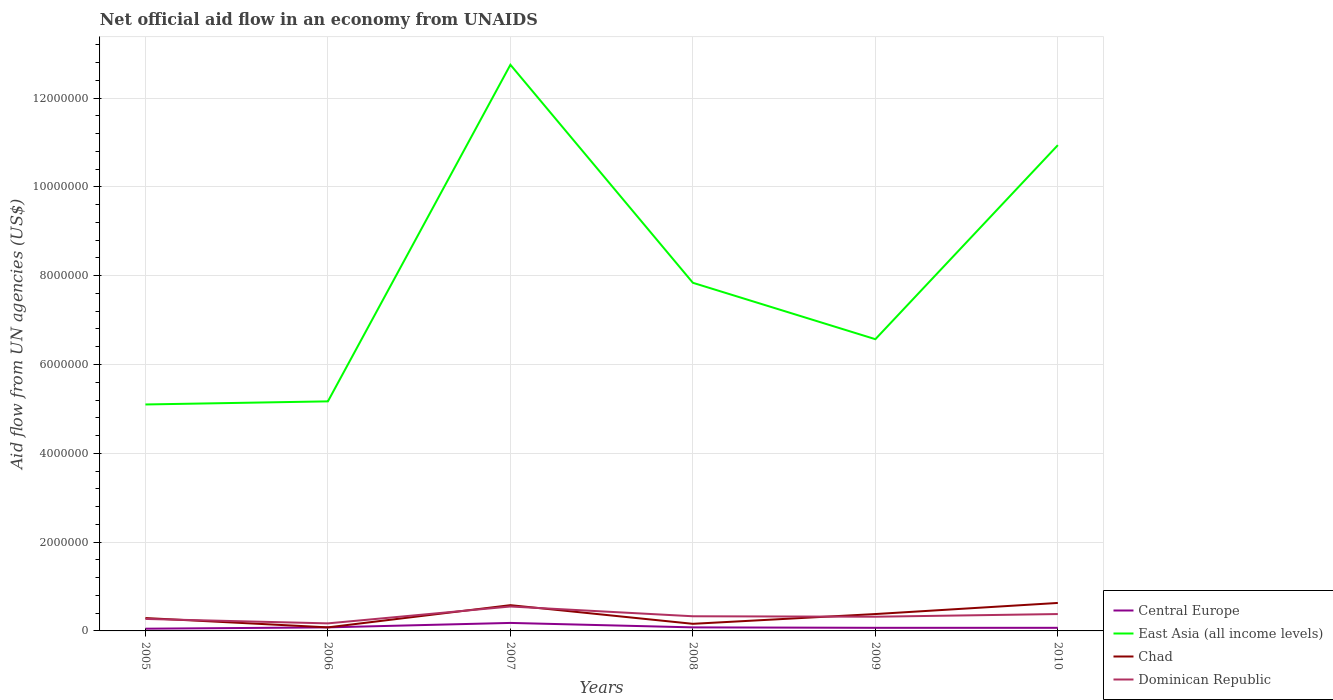How many different coloured lines are there?
Offer a very short reply. 4. Across all years, what is the maximum net official aid flow in Chad?
Your response must be concise. 8.00e+04. What is the total net official aid flow in Central Europe in the graph?
Make the answer very short. 0. What is the difference between the highest and the second highest net official aid flow in Chad?
Ensure brevity in your answer.  5.50e+05. What is the difference between the highest and the lowest net official aid flow in East Asia (all income levels)?
Offer a terse response. 2. How many years are there in the graph?
Keep it short and to the point. 6. What is the difference between two consecutive major ticks on the Y-axis?
Provide a succinct answer. 2.00e+06. How many legend labels are there?
Your answer should be very brief. 4. What is the title of the graph?
Offer a very short reply. Net official aid flow in an economy from UNAIDS. Does "France" appear as one of the legend labels in the graph?
Your response must be concise. No. What is the label or title of the X-axis?
Keep it short and to the point. Years. What is the label or title of the Y-axis?
Keep it short and to the point. Aid flow from UN agencies (US$). What is the Aid flow from UN agencies (US$) of Central Europe in 2005?
Ensure brevity in your answer.  5.00e+04. What is the Aid flow from UN agencies (US$) of East Asia (all income levels) in 2005?
Your answer should be compact. 5.10e+06. What is the Aid flow from UN agencies (US$) in Dominican Republic in 2005?
Your answer should be very brief. 2.70e+05. What is the Aid flow from UN agencies (US$) of East Asia (all income levels) in 2006?
Give a very brief answer. 5.17e+06. What is the Aid flow from UN agencies (US$) of Dominican Republic in 2006?
Provide a succinct answer. 1.70e+05. What is the Aid flow from UN agencies (US$) of Central Europe in 2007?
Your response must be concise. 1.80e+05. What is the Aid flow from UN agencies (US$) in East Asia (all income levels) in 2007?
Keep it short and to the point. 1.28e+07. What is the Aid flow from UN agencies (US$) of Chad in 2007?
Provide a short and direct response. 5.80e+05. What is the Aid flow from UN agencies (US$) of Dominican Republic in 2007?
Keep it short and to the point. 5.50e+05. What is the Aid flow from UN agencies (US$) in East Asia (all income levels) in 2008?
Your response must be concise. 7.84e+06. What is the Aid flow from UN agencies (US$) in Chad in 2008?
Offer a very short reply. 1.60e+05. What is the Aid flow from UN agencies (US$) of Dominican Republic in 2008?
Keep it short and to the point. 3.30e+05. What is the Aid flow from UN agencies (US$) of East Asia (all income levels) in 2009?
Ensure brevity in your answer.  6.57e+06. What is the Aid flow from UN agencies (US$) of Chad in 2009?
Your response must be concise. 3.80e+05. What is the Aid flow from UN agencies (US$) in East Asia (all income levels) in 2010?
Give a very brief answer. 1.09e+07. What is the Aid flow from UN agencies (US$) in Chad in 2010?
Make the answer very short. 6.30e+05. What is the Aid flow from UN agencies (US$) in Dominican Republic in 2010?
Your answer should be very brief. 3.80e+05. Across all years, what is the maximum Aid flow from UN agencies (US$) in East Asia (all income levels)?
Make the answer very short. 1.28e+07. Across all years, what is the maximum Aid flow from UN agencies (US$) in Chad?
Provide a short and direct response. 6.30e+05. Across all years, what is the maximum Aid flow from UN agencies (US$) in Dominican Republic?
Your answer should be very brief. 5.50e+05. Across all years, what is the minimum Aid flow from UN agencies (US$) in Central Europe?
Provide a short and direct response. 5.00e+04. Across all years, what is the minimum Aid flow from UN agencies (US$) in East Asia (all income levels)?
Provide a succinct answer. 5.10e+06. Across all years, what is the minimum Aid flow from UN agencies (US$) in Dominican Republic?
Keep it short and to the point. 1.70e+05. What is the total Aid flow from UN agencies (US$) of Central Europe in the graph?
Offer a very short reply. 5.30e+05. What is the total Aid flow from UN agencies (US$) in East Asia (all income levels) in the graph?
Keep it short and to the point. 4.84e+07. What is the total Aid flow from UN agencies (US$) of Chad in the graph?
Keep it short and to the point. 2.12e+06. What is the total Aid flow from UN agencies (US$) in Dominican Republic in the graph?
Make the answer very short. 2.02e+06. What is the difference between the Aid flow from UN agencies (US$) of Dominican Republic in 2005 and that in 2006?
Your answer should be compact. 1.00e+05. What is the difference between the Aid flow from UN agencies (US$) in East Asia (all income levels) in 2005 and that in 2007?
Give a very brief answer. -7.65e+06. What is the difference between the Aid flow from UN agencies (US$) of Chad in 2005 and that in 2007?
Ensure brevity in your answer.  -2.90e+05. What is the difference between the Aid flow from UN agencies (US$) of Dominican Republic in 2005 and that in 2007?
Offer a terse response. -2.80e+05. What is the difference between the Aid flow from UN agencies (US$) in Central Europe in 2005 and that in 2008?
Offer a terse response. -3.00e+04. What is the difference between the Aid flow from UN agencies (US$) of East Asia (all income levels) in 2005 and that in 2008?
Provide a short and direct response. -2.74e+06. What is the difference between the Aid flow from UN agencies (US$) of Chad in 2005 and that in 2008?
Make the answer very short. 1.30e+05. What is the difference between the Aid flow from UN agencies (US$) in Central Europe in 2005 and that in 2009?
Give a very brief answer. -2.00e+04. What is the difference between the Aid flow from UN agencies (US$) in East Asia (all income levels) in 2005 and that in 2009?
Offer a terse response. -1.47e+06. What is the difference between the Aid flow from UN agencies (US$) of Chad in 2005 and that in 2009?
Offer a very short reply. -9.00e+04. What is the difference between the Aid flow from UN agencies (US$) of Dominican Republic in 2005 and that in 2009?
Offer a very short reply. -5.00e+04. What is the difference between the Aid flow from UN agencies (US$) of Central Europe in 2005 and that in 2010?
Offer a terse response. -2.00e+04. What is the difference between the Aid flow from UN agencies (US$) of East Asia (all income levels) in 2005 and that in 2010?
Your answer should be compact. -5.84e+06. What is the difference between the Aid flow from UN agencies (US$) in Chad in 2005 and that in 2010?
Make the answer very short. -3.40e+05. What is the difference between the Aid flow from UN agencies (US$) of East Asia (all income levels) in 2006 and that in 2007?
Provide a succinct answer. -7.58e+06. What is the difference between the Aid flow from UN agencies (US$) in Chad in 2006 and that in 2007?
Offer a terse response. -5.00e+05. What is the difference between the Aid flow from UN agencies (US$) of Dominican Republic in 2006 and that in 2007?
Your answer should be very brief. -3.80e+05. What is the difference between the Aid flow from UN agencies (US$) of East Asia (all income levels) in 2006 and that in 2008?
Give a very brief answer. -2.67e+06. What is the difference between the Aid flow from UN agencies (US$) in Chad in 2006 and that in 2008?
Your response must be concise. -8.00e+04. What is the difference between the Aid flow from UN agencies (US$) in Dominican Republic in 2006 and that in 2008?
Your answer should be very brief. -1.60e+05. What is the difference between the Aid flow from UN agencies (US$) of Central Europe in 2006 and that in 2009?
Give a very brief answer. 10000. What is the difference between the Aid flow from UN agencies (US$) in East Asia (all income levels) in 2006 and that in 2009?
Your answer should be very brief. -1.40e+06. What is the difference between the Aid flow from UN agencies (US$) in Chad in 2006 and that in 2009?
Your answer should be very brief. -3.00e+05. What is the difference between the Aid flow from UN agencies (US$) in Central Europe in 2006 and that in 2010?
Provide a short and direct response. 10000. What is the difference between the Aid flow from UN agencies (US$) of East Asia (all income levels) in 2006 and that in 2010?
Your answer should be very brief. -5.77e+06. What is the difference between the Aid flow from UN agencies (US$) in Chad in 2006 and that in 2010?
Your answer should be compact. -5.50e+05. What is the difference between the Aid flow from UN agencies (US$) of Dominican Republic in 2006 and that in 2010?
Provide a short and direct response. -2.10e+05. What is the difference between the Aid flow from UN agencies (US$) in East Asia (all income levels) in 2007 and that in 2008?
Ensure brevity in your answer.  4.91e+06. What is the difference between the Aid flow from UN agencies (US$) of Central Europe in 2007 and that in 2009?
Your answer should be very brief. 1.10e+05. What is the difference between the Aid flow from UN agencies (US$) in East Asia (all income levels) in 2007 and that in 2009?
Provide a short and direct response. 6.18e+06. What is the difference between the Aid flow from UN agencies (US$) of Dominican Republic in 2007 and that in 2009?
Provide a succinct answer. 2.30e+05. What is the difference between the Aid flow from UN agencies (US$) in Central Europe in 2007 and that in 2010?
Give a very brief answer. 1.10e+05. What is the difference between the Aid flow from UN agencies (US$) of East Asia (all income levels) in 2007 and that in 2010?
Ensure brevity in your answer.  1.81e+06. What is the difference between the Aid flow from UN agencies (US$) in Chad in 2007 and that in 2010?
Provide a succinct answer. -5.00e+04. What is the difference between the Aid flow from UN agencies (US$) in Dominican Republic in 2007 and that in 2010?
Ensure brevity in your answer.  1.70e+05. What is the difference between the Aid flow from UN agencies (US$) in Central Europe in 2008 and that in 2009?
Your response must be concise. 10000. What is the difference between the Aid flow from UN agencies (US$) of East Asia (all income levels) in 2008 and that in 2009?
Provide a succinct answer. 1.27e+06. What is the difference between the Aid flow from UN agencies (US$) of Dominican Republic in 2008 and that in 2009?
Your response must be concise. 10000. What is the difference between the Aid flow from UN agencies (US$) of Central Europe in 2008 and that in 2010?
Offer a very short reply. 10000. What is the difference between the Aid flow from UN agencies (US$) in East Asia (all income levels) in 2008 and that in 2010?
Your response must be concise. -3.10e+06. What is the difference between the Aid flow from UN agencies (US$) of Chad in 2008 and that in 2010?
Give a very brief answer. -4.70e+05. What is the difference between the Aid flow from UN agencies (US$) of Central Europe in 2009 and that in 2010?
Make the answer very short. 0. What is the difference between the Aid flow from UN agencies (US$) of East Asia (all income levels) in 2009 and that in 2010?
Make the answer very short. -4.37e+06. What is the difference between the Aid flow from UN agencies (US$) of Chad in 2009 and that in 2010?
Provide a short and direct response. -2.50e+05. What is the difference between the Aid flow from UN agencies (US$) in Dominican Republic in 2009 and that in 2010?
Provide a short and direct response. -6.00e+04. What is the difference between the Aid flow from UN agencies (US$) of Central Europe in 2005 and the Aid flow from UN agencies (US$) of East Asia (all income levels) in 2006?
Provide a short and direct response. -5.12e+06. What is the difference between the Aid flow from UN agencies (US$) in Central Europe in 2005 and the Aid flow from UN agencies (US$) in Chad in 2006?
Offer a very short reply. -3.00e+04. What is the difference between the Aid flow from UN agencies (US$) of East Asia (all income levels) in 2005 and the Aid flow from UN agencies (US$) of Chad in 2006?
Provide a short and direct response. 5.02e+06. What is the difference between the Aid flow from UN agencies (US$) of East Asia (all income levels) in 2005 and the Aid flow from UN agencies (US$) of Dominican Republic in 2006?
Offer a very short reply. 4.93e+06. What is the difference between the Aid flow from UN agencies (US$) in Central Europe in 2005 and the Aid flow from UN agencies (US$) in East Asia (all income levels) in 2007?
Offer a very short reply. -1.27e+07. What is the difference between the Aid flow from UN agencies (US$) in Central Europe in 2005 and the Aid flow from UN agencies (US$) in Chad in 2007?
Provide a short and direct response. -5.30e+05. What is the difference between the Aid flow from UN agencies (US$) of Central Europe in 2005 and the Aid flow from UN agencies (US$) of Dominican Republic in 2007?
Make the answer very short. -5.00e+05. What is the difference between the Aid flow from UN agencies (US$) in East Asia (all income levels) in 2005 and the Aid flow from UN agencies (US$) in Chad in 2007?
Ensure brevity in your answer.  4.52e+06. What is the difference between the Aid flow from UN agencies (US$) in East Asia (all income levels) in 2005 and the Aid flow from UN agencies (US$) in Dominican Republic in 2007?
Keep it short and to the point. 4.55e+06. What is the difference between the Aid flow from UN agencies (US$) in Chad in 2005 and the Aid flow from UN agencies (US$) in Dominican Republic in 2007?
Provide a succinct answer. -2.60e+05. What is the difference between the Aid flow from UN agencies (US$) of Central Europe in 2005 and the Aid flow from UN agencies (US$) of East Asia (all income levels) in 2008?
Give a very brief answer. -7.79e+06. What is the difference between the Aid flow from UN agencies (US$) of Central Europe in 2005 and the Aid flow from UN agencies (US$) of Dominican Republic in 2008?
Keep it short and to the point. -2.80e+05. What is the difference between the Aid flow from UN agencies (US$) in East Asia (all income levels) in 2005 and the Aid flow from UN agencies (US$) in Chad in 2008?
Keep it short and to the point. 4.94e+06. What is the difference between the Aid flow from UN agencies (US$) of East Asia (all income levels) in 2005 and the Aid flow from UN agencies (US$) of Dominican Republic in 2008?
Make the answer very short. 4.77e+06. What is the difference between the Aid flow from UN agencies (US$) of Central Europe in 2005 and the Aid flow from UN agencies (US$) of East Asia (all income levels) in 2009?
Make the answer very short. -6.52e+06. What is the difference between the Aid flow from UN agencies (US$) of Central Europe in 2005 and the Aid flow from UN agencies (US$) of Chad in 2009?
Provide a short and direct response. -3.30e+05. What is the difference between the Aid flow from UN agencies (US$) of East Asia (all income levels) in 2005 and the Aid flow from UN agencies (US$) of Chad in 2009?
Provide a short and direct response. 4.72e+06. What is the difference between the Aid flow from UN agencies (US$) in East Asia (all income levels) in 2005 and the Aid flow from UN agencies (US$) in Dominican Republic in 2009?
Make the answer very short. 4.78e+06. What is the difference between the Aid flow from UN agencies (US$) in Central Europe in 2005 and the Aid flow from UN agencies (US$) in East Asia (all income levels) in 2010?
Give a very brief answer. -1.09e+07. What is the difference between the Aid flow from UN agencies (US$) of Central Europe in 2005 and the Aid flow from UN agencies (US$) of Chad in 2010?
Ensure brevity in your answer.  -5.80e+05. What is the difference between the Aid flow from UN agencies (US$) in Central Europe in 2005 and the Aid flow from UN agencies (US$) in Dominican Republic in 2010?
Your answer should be very brief. -3.30e+05. What is the difference between the Aid flow from UN agencies (US$) in East Asia (all income levels) in 2005 and the Aid flow from UN agencies (US$) in Chad in 2010?
Ensure brevity in your answer.  4.47e+06. What is the difference between the Aid flow from UN agencies (US$) of East Asia (all income levels) in 2005 and the Aid flow from UN agencies (US$) of Dominican Republic in 2010?
Ensure brevity in your answer.  4.72e+06. What is the difference between the Aid flow from UN agencies (US$) in Central Europe in 2006 and the Aid flow from UN agencies (US$) in East Asia (all income levels) in 2007?
Your response must be concise. -1.27e+07. What is the difference between the Aid flow from UN agencies (US$) in Central Europe in 2006 and the Aid flow from UN agencies (US$) in Chad in 2007?
Your answer should be very brief. -5.00e+05. What is the difference between the Aid flow from UN agencies (US$) in Central Europe in 2006 and the Aid flow from UN agencies (US$) in Dominican Republic in 2007?
Offer a terse response. -4.70e+05. What is the difference between the Aid flow from UN agencies (US$) in East Asia (all income levels) in 2006 and the Aid flow from UN agencies (US$) in Chad in 2007?
Provide a succinct answer. 4.59e+06. What is the difference between the Aid flow from UN agencies (US$) of East Asia (all income levels) in 2006 and the Aid flow from UN agencies (US$) of Dominican Republic in 2007?
Keep it short and to the point. 4.62e+06. What is the difference between the Aid flow from UN agencies (US$) of Chad in 2006 and the Aid flow from UN agencies (US$) of Dominican Republic in 2007?
Make the answer very short. -4.70e+05. What is the difference between the Aid flow from UN agencies (US$) in Central Europe in 2006 and the Aid flow from UN agencies (US$) in East Asia (all income levels) in 2008?
Provide a short and direct response. -7.76e+06. What is the difference between the Aid flow from UN agencies (US$) of Central Europe in 2006 and the Aid flow from UN agencies (US$) of Chad in 2008?
Your answer should be compact. -8.00e+04. What is the difference between the Aid flow from UN agencies (US$) in East Asia (all income levels) in 2006 and the Aid flow from UN agencies (US$) in Chad in 2008?
Your response must be concise. 5.01e+06. What is the difference between the Aid flow from UN agencies (US$) in East Asia (all income levels) in 2006 and the Aid flow from UN agencies (US$) in Dominican Republic in 2008?
Provide a short and direct response. 4.84e+06. What is the difference between the Aid flow from UN agencies (US$) of Chad in 2006 and the Aid flow from UN agencies (US$) of Dominican Republic in 2008?
Give a very brief answer. -2.50e+05. What is the difference between the Aid flow from UN agencies (US$) in Central Europe in 2006 and the Aid flow from UN agencies (US$) in East Asia (all income levels) in 2009?
Provide a short and direct response. -6.49e+06. What is the difference between the Aid flow from UN agencies (US$) in Central Europe in 2006 and the Aid flow from UN agencies (US$) in Chad in 2009?
Ensure brevity in your answer.  -3.00e+05. What is the difference between the Aid flow from UN agencies (US$) of Central Europe in 2006 and the Aid flow from UN agencies (US$) of Dominican Republic in 2009?
Offer a terse response. -2.40e+05. What is the difference between the Aid flow from UN agencies (US$) of East Asia (all income levels) in 2006 and the Aid flow from UN agencies (US$) of Chad in 2009?
Give a very brief answer. 4.79e+06. What is the difference between the Aid flow from UN agencies (US$) of East Asia (all income levels) in 2006 and the Aid flow from UN agencies (US$) of Dominican Republic in 2009?
Make the answer very short. 4.85e+06. What is the difference between the Aid flow from UN agencies (US$) in Chad in 2006 and the Aid flow from UN agencies (US$) in Dominican Republic in 2009?
Provide a short and direct response. -2.40e+05. What is the difference between the Aid flow from UN agencies (US$) in Central Europe in 2006 and the Aid flow from UN agencies (US$) in East Asia (all income levels) in 2010?
Give a very brief answer. -1.09e+07. What is the difference between the Aid flow from UN agencies (US$) in Central Europe in 2006 and the Aid flow from UN agencies (US$) in Chad in 2010?
Ensure brevity in your answer.  -5.50e+05. What is the difference between the Aid flow from UN agencies (US$) of Central Europe in 2006 and the Aid flow from UN agencies (US$) of Dominican Republic in 2010?
Your answer should be compact. -3.00e+05. What is the difference between the Aid flow from UN agencies (US$) of East Asia (all income levels) in 2006 and the Aid flow from UN agencies (US$) of Chad in 2010?
Make the answer very short. 4.54e+06. What is the difference between the Aid flow from UN agencies (US$) of East Asia (all income levels) in 2006 and the Aid flow from UN agencies (US$) of Dominican Republic in 2010?
Make the answer very short. 4.79e+06. What is the difference between the Aid flow from UN agencies (US$) of Central Europe in 2007 and the Aid flow from UN agencies (US$) of East Asia (all income levels) in 2008?
Provide a short and direct response. -7.66e+06. What is the difference between the Aid flow from UN agencies (US$) in Central Europe in 2007 and the Aid flow from UN agencies (US$) in Dominican Republic in 2008?
Your answer should be very brief. -1.50e+05. What is the difference between the Aid flow from UN agencies (US$) in East Asia (all income levels) in 2007 and the Aid flow from UN agencies (US$) in Chad in 2008?
Offer a very short reply. 1.26e+07. What is the difference between the Aid flow from UN agencies (US$) in East Asia (all income levels) in 2007 and the Aid flow from UN agencies (US$) in Dominican Republic in 2008?
Ensure brevity in your answer.  1.24e+07. What is the difference between the Aid flow from UN agencies (US$) in Central Europe in 2007 and the Aid flow from UN agencies (US$) in East Asia (all income levels) in 2009?
Provide a short and direct response. -6.39e+06. What is the difference between the Aid flow from UN agencies (US$) of East Asia (all income levels) in 2007 and the Aid flow from UN agencies (US$) of Chad in 2009?
Your answer should be compact. 1.24e+07. What is the difference between the Aid flow from UN agencies (US$) of East Asia (all income levels) in 2007 and the Aid flow from UN agencies (US$) of Dominican Republic in 2009?
Make the answer very short. 1.24e+07. What is the difference between the Aid flow from UN agencies (US$) of Chad in 2007 and the Aid flow from UN agencies (US$) of Dominican Republic in 2009?
Offer a very short reply. 2.60e+05. What is the difference between the Aid flow from UN agencies (US$) in Central Europe in 2007 and the Aid flow from UN agencies (US$) in East Asia (all income levels) in 2010?
Provide a succinct answer. -1.08e+07. What is the difference between the Aid flow from UN agencies (US$) in Central Europe in 2007 and the Aid flow from UN agencies (US$) in Chad in 2010?
Your answer should be very brief. -4.50e+05. What is the difference between the Aid flow from UN agencies (US$) in Central Europe in 2007 and the Aid flow from UN agencies (US$) in Dominican Republic in 2010?
Your answer should be very brief. -2.00e+05. What is the difference between the Aid flow from UN agencies (US$) of East Asia (all income levels) in 2007 and the Aid flow from UN agencies (US$) of Chad in 2010?
Your response must be concise. 1.21e+07. What is the difference between the Aid flow from UN agencies (US$) in East Asia (all income levels) in 2007 and the Aid flow from UN agencies (US$) in Dominican Republic in 2010?
Your response must be concise. 1.24e+07. What is the difference between the Aid flow from UN agencies (US$) of Central Europe in 2008 and the Aid flow from UN agencies (US$) of East Asia (all income levels) in 2009?
Offer a terse response. -6.49e+06. What is the difference between the Aid flow from UN agencies (US$) of Central Europe in 2008 and the Aid flow from UN agencies (US$) of Chad in 2009?
Ensure brevity in your answer.  -3.00e+05. What is the difference between the Aid flow from UN agencies (US$) in East Asia (all income levels) in 2008 and the Aid flow from UN agencies (US$) in Chad in 2009?
Give a very brief answer. 7.46e+06. What is the difference between the Aid flow from UN agencies (US$) of East Asia (all income levels) in 2008 and the Aid flow from UN agencies (US$) of Dominican Republic in 2009?
Give a very brief answer. 7.52e+06. What is the difference between the Aid flow from UN agencies (US$) in Chad in 2008 and the Aid flow from UN agencies (US$) in Dominican Republic in 2009?
Provide a succinct answer. -1.60e+05. What is the difference between the Aid flow from UN agencies (US$) in Central Europe in 2008 and the Aid flow from UN agencies (US$) in East Asia (all income levels) in 2010?
Make the answer very short. -1.09e+07. What is the difference between the Aid flow from UN agencies (US$) in Central Europe in 2008 and the Aid flow from UN agencies (US$) in Chad in 2010?
Offer a terse response. -5.50e+05. What is the difference between the Aid flow from UN agencies (US$) of East Asia (all income levels) in 2008 and the Aid flow from UN agencies (US$) of Chad in 2010?
Ensure brevity in your answer.  7.21e+06. What is the difference between the Aid flow from UN agencies (US$) of East Asia (all income levels) in 2008 and the Aid flow from UN agencies (US$) of Dominican Republic in 2010?
Provide a succinct answer. 7.46e+06. What is the difference between the Aid flow from UN agencies (US$) of Chad in 2008 and the Aid flow from UN agencies (US$) of Dominican Republic in 2010?
Your response must be concise. -2.20e+05. What is the difference between the Aid flow from UN agencies (US$) in Central Europe in 2009 and the Aid flow from UN agencies (US$) in East Asia (all income levels) in 2010?
Your answer should be very brief. -1.09e+07. What is the difference between the Aid flow from UN agencies (US$) in Central Europe in 2009 and the Aid flow from UN agencies (US$) in Chad in 2010?
Offer a very short reply. -5.60e+05. What is the difference between the Aid flow from UN agencies (US$) of Central Europe in 2009 and the Aid flow from UN agencies (US$) of Dominican Republic in 2010?
Your response must be concise. -3.10e+05. What is the difference between the Aid flow from UN agencies (US$) in East Asia (all income levels) in 2009 and the Aid flow from UN agencies (US$) in Chad in 2010?
Make the answer very short. 5.94e+06. What is the difference between the Aid flow from UN agencies (US$) in East Asia (all income levels) in 2009 and the Aid flow from UN agencies (US$) in Dominican Republic in 2010?
Your answer should be very brief. 6.19e+06. What is the average Aid flow from UN agencies (US$) of Central Europe per year?
Your response must be concise. 8.83e+04. What is the average Aid flow from UN agencies (US$) in East Asia (all income levels) per year?
Provide a short and direct response. 8.06e+06. What is the average Aid flow from UN agencies (US$) of Chad per year?
Your answer should be compact. 3.53e+05. What is the average Aid flow from UN agencies (US$) of Dominican Republic per year?
Make the answer very short. 3.37e+05. In the year 2005, what is the difference between the Aid flow from UN agencies (US$) in Central Europe and Aid flow from UN agencies (US$) in East Asia (all income levels)?
Your answer should be compact. -5.05e+06. In the year 2005, what is the difference between the Aid flow from UN agencies (US$) of Central Europe and Aid flow from UN agencies (US$) of Chad?
Your response must be concise. -2.40e+05. In the year 2005, what is the difference between the Aid flow from UN agencies (US$) in Central Europe and Aid flow from UN agencies (US$) in Dominican Republic?
Ensure brevity in your answer.  -2.20e+05. In the year 2005, what is the difference between the Aid flow from UN agencies (US$) of East Asia (all income levels) and Aid flow from UN agencies (US$) of Chad?
Your answer should be very brief. 4.81e+06. In the year 2005, what is the difference between the Aid flow from UN agencies (US$) in East Asia (all income levels) and Aid flow from UN agencies (US$) in Dominican Republic?
Provide a succinct answer. 4.83e+06. In the year 2006, what is the difference between the Aid flow from UN agencies (US$) in Central Europe and Aid flow from UN agencies (US$) in East Asia (all income levels)?
Offer a terse response. -5.09e+06. In the year 2006, what is the difference between the Aid flow from UN agencies (US$) in Central Europe and Aid flow from UN agencies (US$) in Dominican Republic?
Make the answer very short. -9.00e+04. In the year 2006, what is the difference between the Aid flow from UN agencies (US$) of East Asia (all income levels) and Aid flow from UN agencies (US$) of Chad?
Make the answer very short. 5.09e+06. In the year 2006, what is the difference between the Aid flow from UN agencies (US$) in East Asia (all income levels) and Aid flow from UN agencies (US$) in Dominican Republic?
Provide a succinct answer. 5.00e+06. In the year 2006, what is the difference between the Aid flow from UN agencies (US$) in Chad and Aid flow from UN agencies (US$) in Dominican Republic?
Offer a very short reply. -9.00e+04. In the year 2007, what is the difference between the Aid flow from UN agencies (US$) in Central Europe and Aid flow from UN agencies (US$) in East Asia (all income levels)?
Offer a very short reply. -1.26e+07. In the year 2007, what is the difference between the Aid flow from UN agencies (US$) in Central Europe and Aid flow from UN agencies (US$) in Chad?
Your answer should be very brief. -4.00e+05. In the year 2007, what is the difference between the Aid flow from UN agencies (US$) of Central Europe and Aid flow from UN agencies (US$) of Dominican Republic?
Give a very brief answer. -3.70e+05. In the year 2007, what is the difference between the Aid flow from UN agencies (US$) in East Asia (all income levels) and Aid flow from UN agencies (US$) in Chad?
Your answer should be very brief. 1.22e+07. In the year 2007, what is the difference between the Aid flow from UN agencies (US$) of East Asia (all income levels) and Aid flow from UN agencies (US$) of Dominican Republic?
Offer a very short reply. 1.22e+07. In the year 2008, what is the difference between the Aid flow from UN agencies (US$) of Central Europe and Aid flow from UN agencies (US$) of East Asia (all income levels)?
Your answer should be compact. -7.76e+06. In the year 2008, what is the difference between the Aid flow from UN agencies (US$) of East Asia (all income levels) and Aid flow from UN agencies (US$) of Chad?
Provide a short and direct response. 7.68e+06. In the year 2008, what is the difference between the Aid flow from UN agencies (US$) of East Asia (all income levels) and Aid flow from UN agencies (US$) of Dominican Republic?
Keep it short and to the point. 7.51e+06. In the year 2009, what is the difference between the Aid flow from UN agencies (US$) of Central Europe and Aid flow from UN agencies (US$) of East Asia (all income levels)?
Make the answer very short. -6.50e+06. In the year 2009, what is the difference between the Aid flow from UN agencies (US$) of Central Europe and Aid flow from UN agencies (US$) of Chad?
Provide a succinct answer. -3.10e+05. In the year 2009, what is the difference between the Aid flow from UN agencies (US$) in East Asia (all income levels) and Aid flow from UN agencies (US$) in Chad?
Your response must be concise. 6.19e+06. In the year 2009, what is the difference between the Aid flow from UN agencies (US$) in East Asia (all income levels) and Aid flow from UN agencies (US$) in Dominican Republic?
Offer a very short reply. 6.25e+06. In the year 2009, what is the difference between the Aid flow from UN agencies (US$) in Chad and Aid flow from UN agencies (US$) in Dominican Republic?
Your answer should be compact. 6.00e+04. In the year 2010, what is the difference between the Aid flow from UN agencies (US$) of Central Europe and Aid flow from UN agencies (US$) of East Asia (all income levels)?
Make the answer very short. -1.09e+07. In the year 2010, what is the difference between the Aid flow from UN agencies (US$) in Central Europe and Aid flow from UN agencies (US$) in Chad?
Provide a short and direct response. -5.60e+05. In the year 2010, what is the difference between the Aid flow from UN agencies (US$) of Central Europe and Aid flow from UN agencies (US$) of Dominican Republic?
Offer a terse response. -3.10e+05. In the year 2010, what is the difference between the Aid flow from UN agencies (US$) of East Asia (all income levels) and Aid flow from UN agencies (US$) of Chad?
Keep it short and to the point. 1.03e+07. In the year 2010, what is the difference between the Aid flow from UN agencies (US$) of East Asia (all income levels) and Aid flow from UN agencies (US$) of Dominican Republic?
Offer a very short reply. 1.06e+07. What is the ratio of the Aid flow from UN agencies (US$) in Central Europe in 2005 to that in 2006?
Offer a very short reply. 0.62. What is the ratio of the Aid flow from UN agencies (US$) in East Asia (all income levels) in 2005 to that in 2006?
Provide a succinct answer. 0.99. What is the ratio of the Aid flow from UN agencies (US$) in Chad in 2005 to that in 2006?
Your answer should be very brief. 3.62. What is the ratio of the Aid flow from UN agencies (US$) of Dominican Republic in 2005 to that in 2006?
Your response must be concise. 1.59. What is the ratio of the Aid flow from UN agencies (US$) of Central Europe in 2005 to that in 2007?
Provide a short and direct response. 0.28. What is the ratio of the Aid flow from UN agencies (US$) of East Asia (all income levels) in 2005 to that in 2007?
Make the answer very short. 0.4. What is the ratio of the Aid flow from UN agencies (US$) of Chad in 2005 to that in 2007?
Your answer should be compact. 0.5. What is the ratio of the Aid flow from UN agencies (US$) in Dominican Republic in 2005 to that in 2007?
Offer a terse response. 0.49. What is the ratio of the Aid flow from UN agencies (US$) in East Asia (all income levels) in 2005 to that in 2008?
Your answer should be compact. 0.65. What is the ratio of the Aid flow from UN agencies (US$) of Chad in 2005 to that in 2008?
Offer a terse response. 1.81. What is the ratio of the Aid flow from UN agencies (US$) of Dominican Republic in 2005 to that in 2008?
Give a very brief answer. 0.82. What is the ratio of the Aid flow from UN agencies (US$) in East Asia (all income levels) in 2005 to that in 2009?
Your answer should be very brief. 0.78. What is the ratio of the Aid flow from UN agencies (US$) of Chad in 2005 to that in 2009?
Ensure brevity in your answer.  0.76. What is the ratio of the Aid flow from UN agencies (US$) in Dominican Republic in 2005 to that in 2009?
Offer a terse response. 0.84. What is the ratio of the Aid flow from UN agencies (US$) in Central Europe in 2005 to that in 2010?
Offer a terse response. 0.71. What is the ratio of the Aid flow from UN agencies (US$) in East Asia (all income levels) in 2005 to that in 2010?
Make the answer very short. 0.47. What is the ratio of the Aid flow from UN agencies (US$) of Chad in 2005 to that in 2010?
Offer a very short reply. 0.46. What is the ratio of the Aid flow from UN agencies (US$) of Dominican Republic in 2005 to that in 2010?
Keep it short and to the point. 0.71. What is the ratio of the Aid flow from UN agencies (US$) of Central Europe in 2006 to that in 2007?
Provide a succinct answer. 0.44. What is the ratio of the Aid flow from UN agencies (US$) in East Asia (all income levels) in 2006 to that in 2007?
Provide a succinct answer. 0.41. What is the ratio of the Aid flow from UN agencies (US$) of Chad in 2006 to that in 2007?
Provide a succinct answer. 0.14. What is the ratio of the Aid flow from UN agencies (US$) in Dominican Republic in 2006 to that in 2007?
Give a very brief answer. 0.31. What is the ratio of the Aid flow from UN agencies (US$) in East Asia (all income levels) in 2006 to that in 2008?
Offer a very short reply. 0.66. What is the ratio of the Aid flow from UN agencies (US$) in Dominican Republic in 2006 to that in 2008?
Make the answer very short. 0.52. What is the ratio of the Aid flow from UN agencies (US$) in East Asia (all income levels) in 2006 to that in 2009?
Give a very brief answer. 0.79. What is the ratio of the Aid flow from UN agencies (US$) in Chad in 2006 to that in 2009?
Make the answer very short. 0.21. What is the ratio of the Aid flow from UN agencies (US$) in Dominican Republic in 2006 to that in 2009?
Provide a succinct answer. 0.53. What is the ratio of the Aid flow from UN agencies (US$) of Central Europe in 2006 to that in 2010?
Your response must be concise. 1.14. What is the ratio of the Aid flow from UN agencies (US$) of East Asia (all income levels) in 2006 to that in 2010?
Your response must be concise. 0.47. What is the ratio of the Aid flow from UN agencies (US$) in Chad in 2006 to that in 2010?
Provide a short and direct response. 0.13. What is the ratio of the Aid flow from UN agencies (US$) in Dominican Republic in 2006 to that in 2010?
Your response must be concise. 0.45. What is the ratio of the Aid flow from UN agencies (US$) in Central Europe in 2007 to that in 2008?
Your answer should be compact. 2.25. What is the ratio of the Aid flow from UN agencies (US$) of East Asia (all income levels) in 2007 to that in 2008?
Keep it short and to the point. 1.63. What is the ratio of the Aid flow from UN agencies (US$) in Chad in 2007 to that in 2008?
Provide a succinct answer. 3.62. What is the ratio of the Aid flow from UN agencies (US$) of Central Europe in 2007 to that in 2009?
Make the answer very short. 2.57. What is the ratio of the Aid flow from UN agencies (US$) in East Asia (all income levels) in 2007 to that in 2009?
Your answer should be compact. 1.94. What is the ratio of the Aid flow from UN agencies (US$) of Chad in 2007 to that in 2009?
Your response must be concise. 1.53. What is the ratio of the Aid flow from UN agencies (US$) in Dominican Republic in 2007 to that in 2009?
Your response must be concise. 1.72. What is the ratio of the Aid flow from UN agencies (US$) in Central Europe in 2007 to that in 2010?
Make the answer very short. 2.57. What is the ratio of the Aid flow from UN agencies (US$) in East Asia (all income levels) in 2007 to that in 2010?
Offer a very short reply. 1.17. What is the ratio of the Aid flow from UN agencies (US$) of Chad in 2007 to that in 2010?
Your answer should be very brief. 0.92. What is the ratio of the Aid flow from UN agencies (US$) in Dominican Republic in 2007 to that in 2010?
Keep it short and to the point. 1.45. What is the ratio of the Aid flow from UN agencies (US$) of Central Europe in 2008 to that in 2009?
Keep it short and to the point. 1.14. What is the ratio of the Aid flow from UN agencies (US$) in East Asia (all income levels) in 2008 to that in 2009?
Offer a very short reply. 1.19. What is the ratio of the Aid flow from UN agencies (US$) of Chad in 2008 to that in 2009?
Your answer should be compact. 0.42. What is the ratio of the Aid flow from UN agencies (US$) of Dominican Republic in 2008 to that in 2009?
Offer a very short reply. 1.03. What is the ratio of the Aid flow from UN agencies (US$) of East Asia (all income levels) in 2008 to that in 2010?
Provide a short and direct response. 0.72. What is the ratio of the Aid flow from UN agencies (US$) in Chad in 2008 to that in 2010?
Your response must be concise. 0.25. What is the ratio of the Aid flow from UN agencies (US$) in Dominican Republic in 2008 to that in 2010?
Offer a very short reply. 0.87. What is the ratio of the Aid flow from UN agencies (US$) of East Asia (all income levels) in 2009 to that in 2010?
Provide a short and direct response. 0.6. What is the ratio of the Aid flow from UN agencies (US$) of Chad in 2009 to that in 2010?
Your answer should be very brief. 0.6. What is the ratio of the Aid flow from UN agencies (US$) of Dominican Republic in 2009 to that in 2010?
Keep it short and to the point. 0.84. What is the difference between the highest and the second highest Aid flow from UN agencies (US$) of Central Europe?
Provide a succinct answer. 1.00e+05. What is the difference between the highest and the second highest Aid flow from UN agencies (US$) of East Asia (all income levels)?
Keep it short and to the point. 1.81e+06. What is the difference between the highest and the second highest Aid flow from UN agencies (US$) in Chad?
Your answer should be compact. 5.00e+04. What is the difference between the highest and the second highest Aid flow from UN agencies (US$) of Dominican Republic?
Your response must be concise. 1.70e+05. What is the difference between the highest and the lowest Aid flow from UN agencies (US$) in East Asia (all income levels)?
Keep it short and to the point. 7.65e+06. What is the difference between the highest and the lowest Aid flow from UN agencies (US$) of Dominican Republic?
Offer a very short reply. 3.80e+05. 